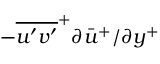<formula> <loc_0><loc_0><loc_500><loc_500>- \overline { { u ^ { \prime } v ^ { \prime } } } ^ { + } \partial \bar { u } ^ { + } / \partial y ^ { + }</formula> 